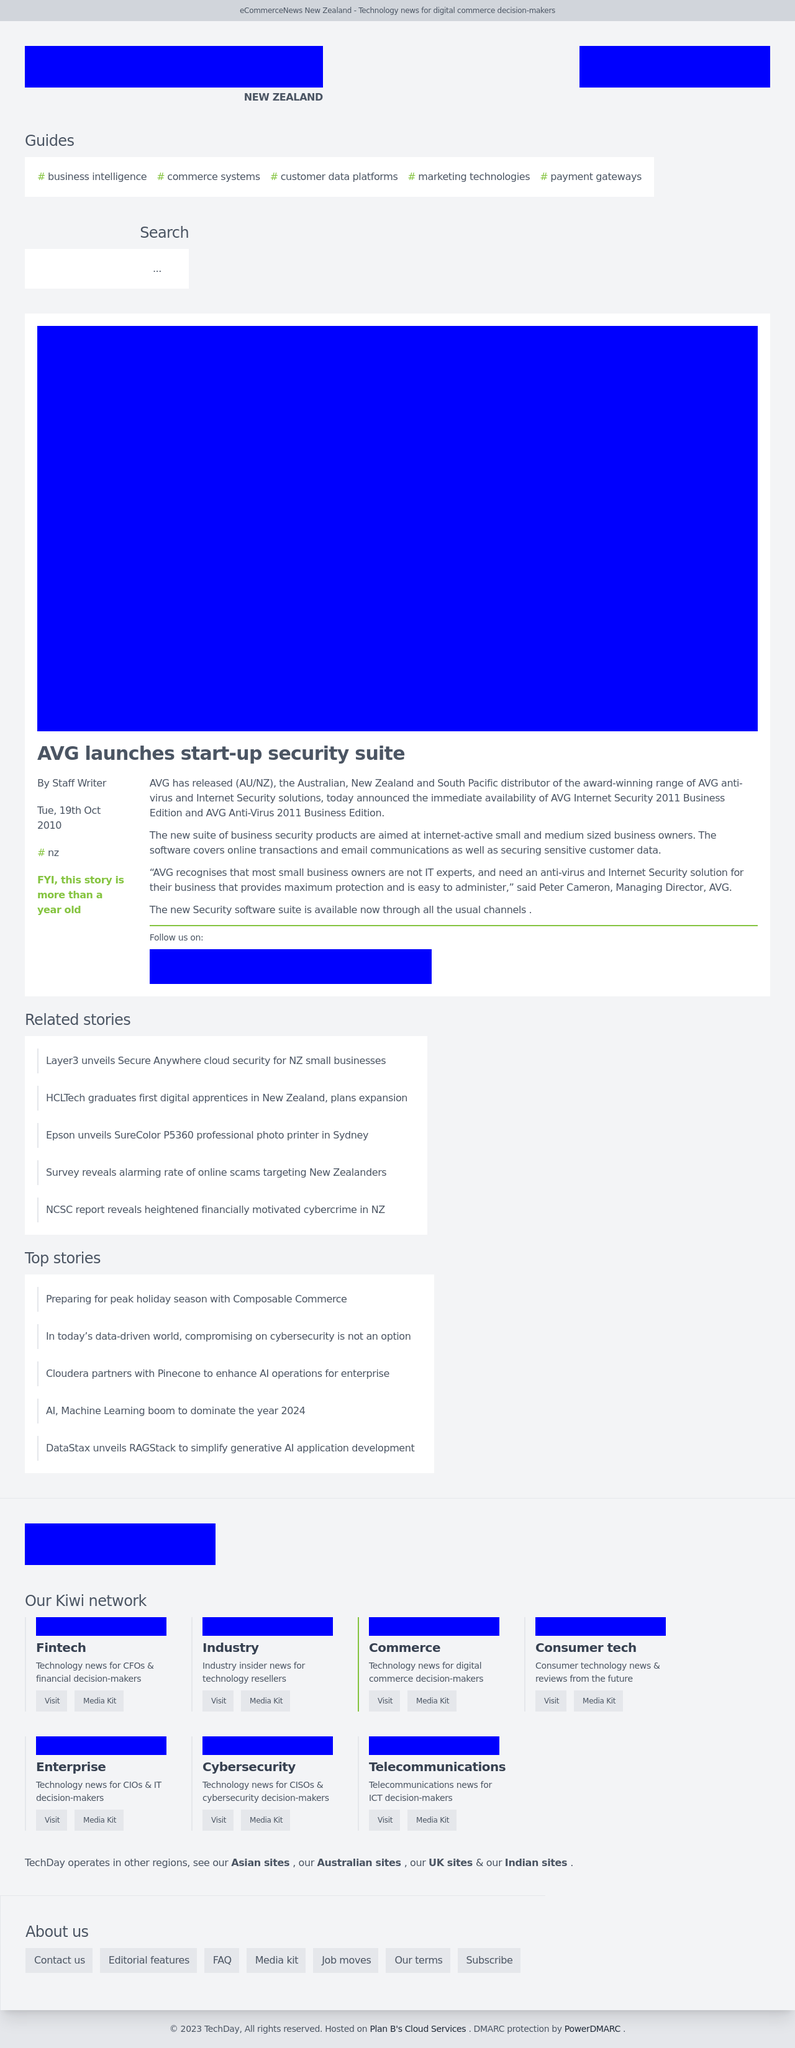How can I start building this website with HTML from the ground up? To begin constructing a website using HTML, start by setting up the basic structure with a DOCTYPE declaration, the html element with a language attribute, and the head section that includes the title, metadata for SEO, and character encoding. Next, establish the viewport for mobile responsiveness, add styles or link to a stylesheet, and create the body of your HTML with structured content using semantic tags like header, nav, main, section, article, and footer to lay the foundation of your site's layout. 